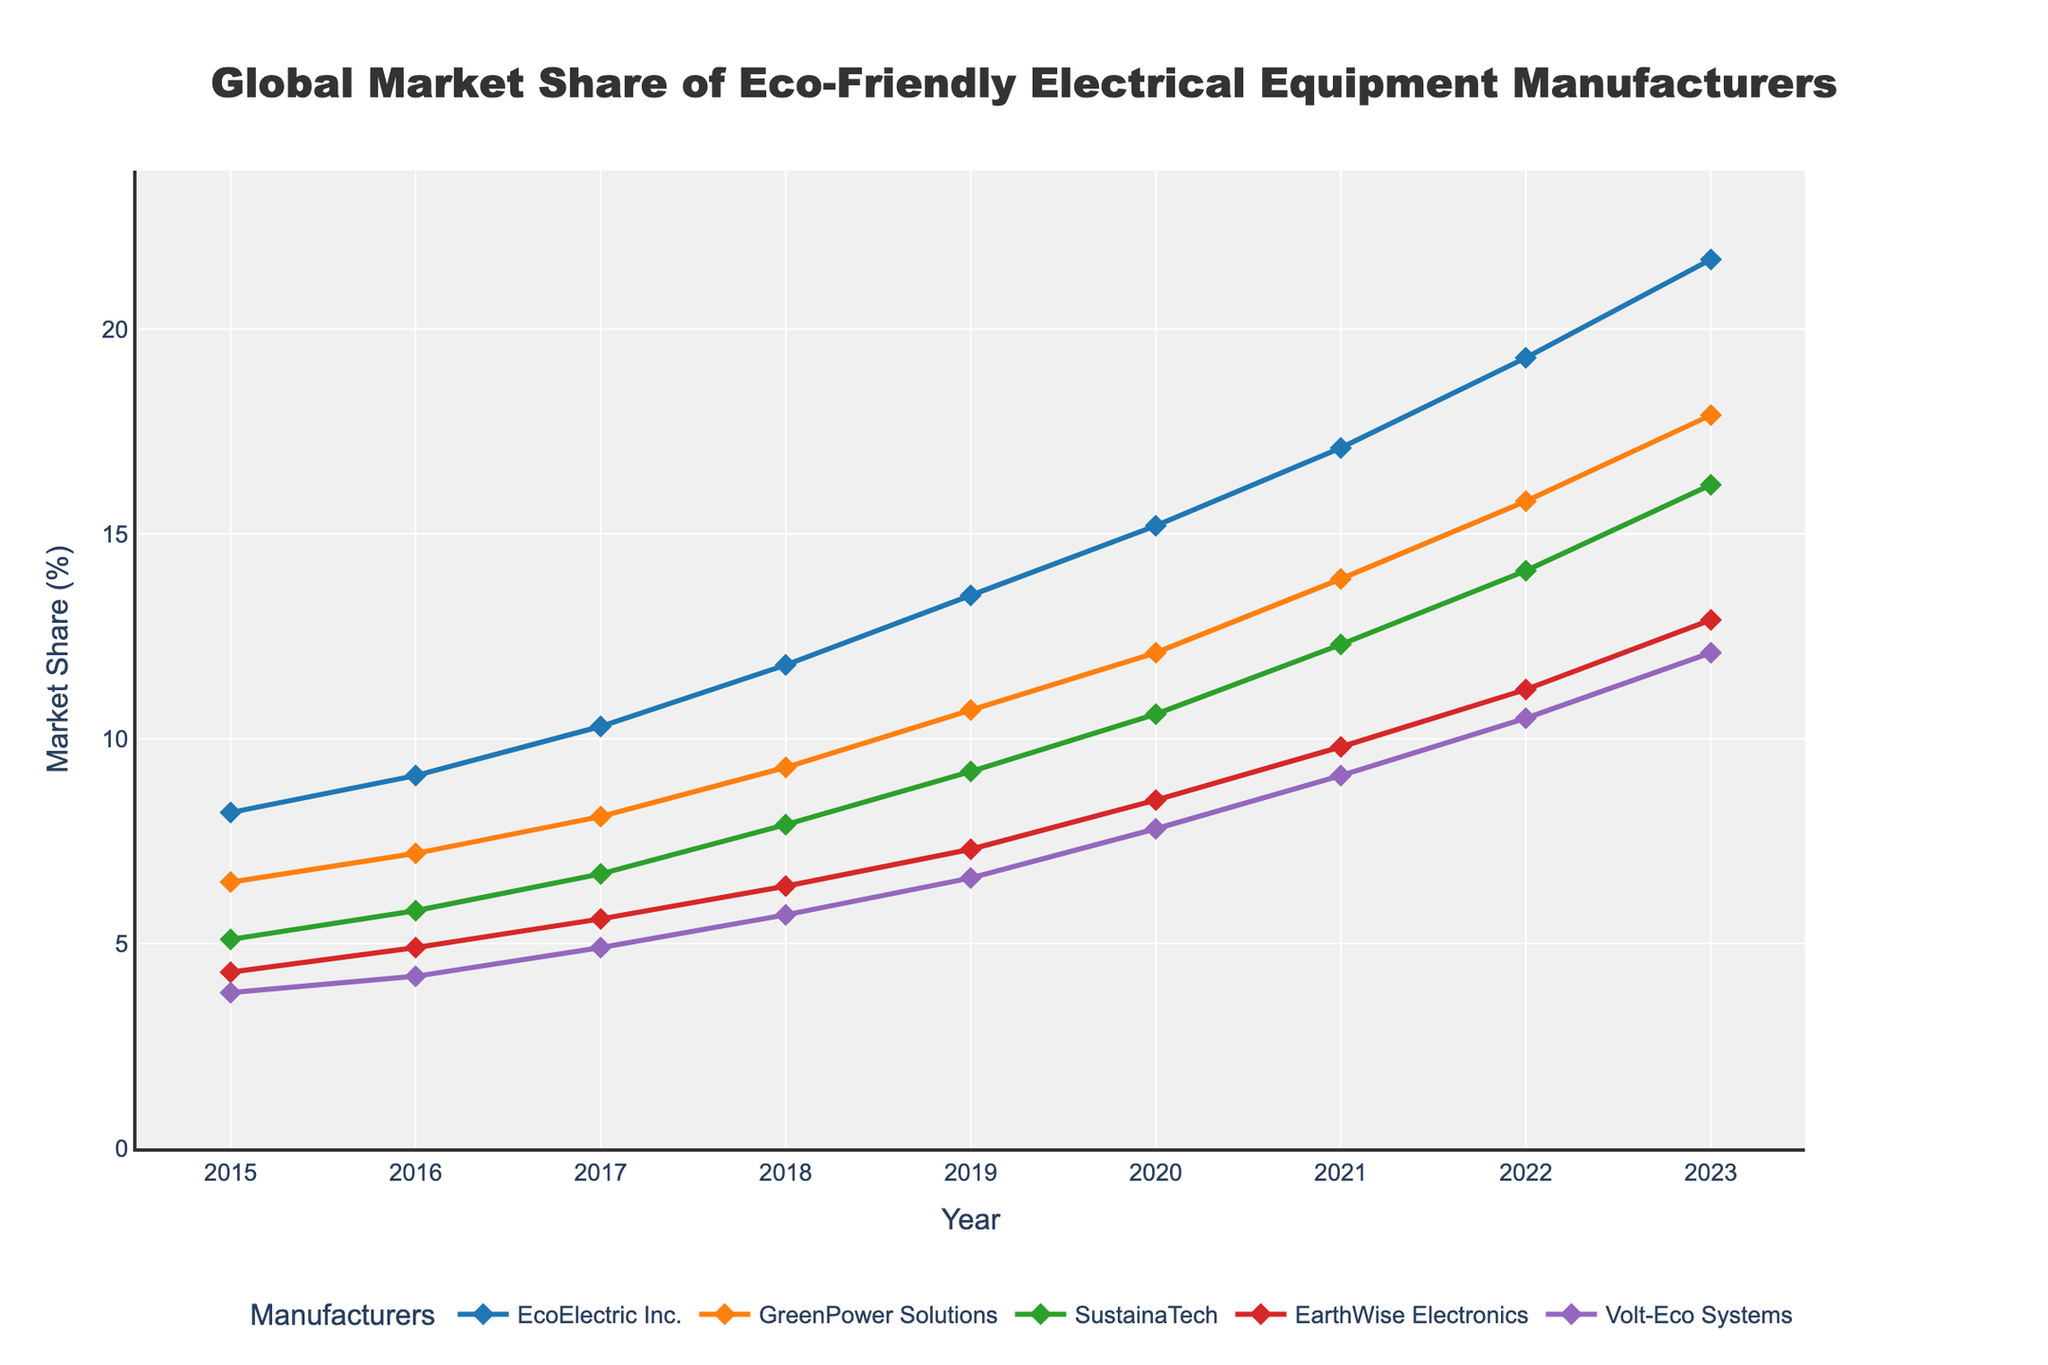What's the market share trend of EcoElectric Inc. from 2015 to 2023? The market share of EcoElectric Inc. shows a consistent upward trend over the years. Starting from 8.2% in 2015 and reaching 21.7% in 2023.
Answer: Consistently increasing Which company has the highest market share in 2023? By visually inspecting the lines at the 2023 mark, EcoElectric Inc. has the highest market share compared to the others.
Answer: EcoElectric Inc How does the market share growth of EarthWise Electronics between 2019 and 2020 compare with its growth between 2022 and 2023? EarthWise Electronics' market share grew from 7.3% in 2019 to 8.5% in 2020, a growth of 1.2%. Between 2022 and 2023, it grew from 11.2% to 12.9%, a growth of 1.7%.
Answer: Growth was higher between 2022 and 2023 What is the average market share of Vol-eco Systems across all the years? Summing the values from 2015 to 2023 (3.8 + 4.2 + 4.9 + 5.7 + 6.6 + 7.8 + 9.1 + 10.5 + 12.1) and dividing by 9 years gives 7.3%.
Answer: 7.3% Which two companies have the closest market share in 2017? In 2017, the market shares are EcoElectric Inc. (10.3%), GreenPower Solutions (8.1%), SustainaTech (6.7%), EarthWise Electronics (5.6%), and Volt-Eco Systems (4.9%). The closest values are SustainaTech and EarthWise Electronics (6.7% and 5.6%).
Answer: SustainaTech and EarthWise Electronics From the data, which company experienced the most significant jump in market share in a single year? Looking at the year-over-year changes, EcoElectric Inc. had a significant jump from 2022 (19.3%) to 2023 (21.7%), an increase of 2.4%.
Answer: EcoElectric Inc How has GreenPower Solutions' market share changed from 2015 to 2023, and how does this compare to EcoElectric Inc.'s change over the same period? GreenPower Solutions increased from 6.5% in 2015 to 17.9% in 2023, a total increase of 11.4%. EcoElectric Inc. increased from 8.2% to 21.7%, a total increase of 13.5%. Thus, EcoElectric Inc. had a higher total increase compared to GreenPower Solutions.
Answer: EcoElectric Inc. had a higher increase Which company's market share has the most steadiness (least variability) throughout the period? By visually assessing the lines, Volt-Eco Systems appears to have the most consistent (least volatile) gradual increase without sharp inclines or declines.
Answer: Volt-Eco Systems By how much did SustainaTech's market share increase from 2018 to 2020? SustainaTech increased from 7.9% in 2018 to 10.6% in 2020. The increase is 10.6 - 7.9 = 2.7%.
Answer: 2.7% 